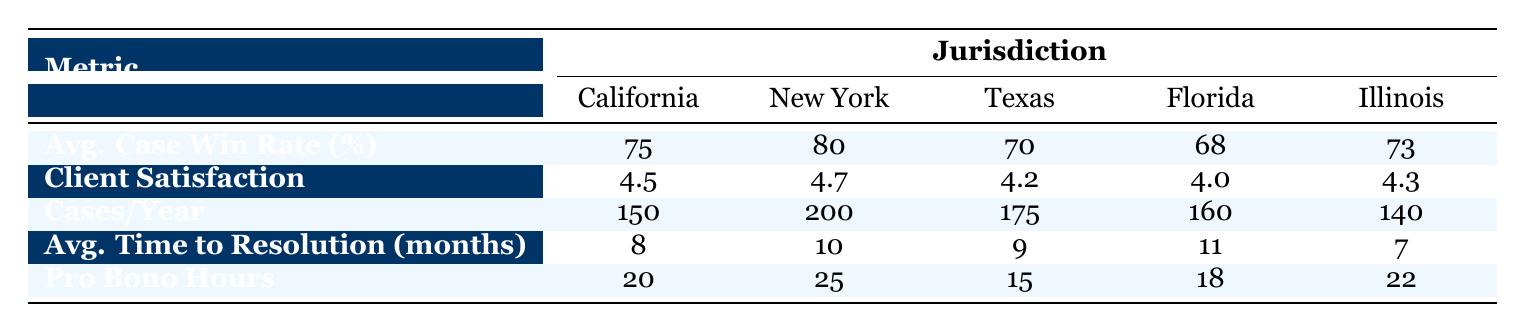What is the Average Case Win Rate in New York? The table shows that the Average Case Win Rate in New York is listed as 80%.
Answer: 80% Which jurisdiction has the highest Client Satisfaction Score? Comparing the Client Satisfaction Scores from the table, New York has the highest score at 4.7.
Answer: New York What is the total number of Cases Handled Per Year for California and Illinois combined? To find this, sum the Cases Handled Per Year for California (150) and Illinois (140): 150 + 140 = 290.
Answer: 290 True or False: The Average Time to Resolution in Texas is less than the Average Time to Resolution in Florida. The Average Time to Resolution in Texas is 9 months, while in Florida, it is 11 months. Since 9 is less than 11, the statement is true.
Answer: True Which jurisdiction has the lowest Pro Bono Hours and what are those hours? By comparing the Pro Bono Hours across jurisdictions, Texas has the lowest at 15 hours.
Answer: Texas, 15 If we consider the Average Case Win Rate, which two jurisdictions combined have a rate greater than California’s? California has an Average Case Win Rate of 75%. New York (80%) and Texas (70%) combine to exceed this. 80 + 70 = 150, and 150/2 = 75; combining New York and Illinois (73) also works: they exceed 75.
Answer: New York and Texas What is the difference in the Average Time to Resolution between Illinois and California? Illinois has an Average Time to Resolution of 7 months, while California’s is 8 months. The difference is 8 - 7 = 1 month.
Answer: 1 month Which jurisdiction handles the most cases per year and how many cases do they handle? According to the table, New York handles the most cases at 200 per year.
Answer: New York, 200 What is the average Client Satisfaction Score across all jurisdictions? To calculate the average, add all the scores (4.5 + 4.7 + 4.2 + 4.0 + 4.3 = 22.7) and then divide by the number of jurisdictions (5): 22.7 / 5 = 4.54.
Answer: 4.54 